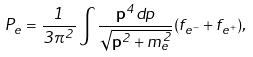Convert formula to latex. <formula><loc_0><loc_0><loc_500><loc_500>P _ { e } = \frac { 1 } { 3 \pi ^ { 2 } } \int \frac { { \mathbf p ^ { 4 } } d p } { \sqrt { { \mathbf p } ^ { 2 } + m _ { e } ^ { 2 } } } ( f _ { e ^ { - } } + f _ { e ^ { + } } ) ,</formula> 